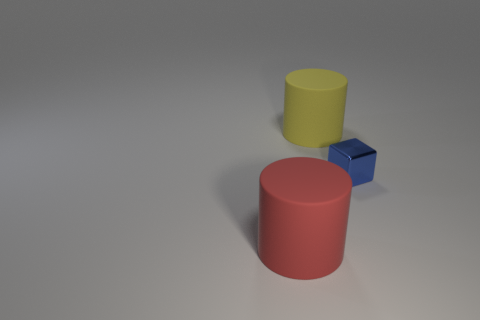What material is the thing right of the large matte object that is behind the object right of the large yellow cylinder made of?
Give a very brief answer. Metal. There is a object that is to the left of the tiny blue metallic object and on the right side of the red cylinder; what size is it?
Provide a short and direct response. Large. How many cylinders are tiny blue metal objects or matte things?
Keep it short and to the point. 2. There is another cylinder that is the same size as the yellow cylinder; what is its color?
Offer a very short reply. Red. Are there any other things that are the same shape as the shiny thing?
Your answer should be compact. No. The other large rubber object that is the same shape as the red rubber object is what color?
Provide a succinct answer. Yellow. How many things are large green metallic cylinders or things that are on the right side of the red cylinder?
Keep it short and to the point. 2. Are there fewer big yellow things that are right of the blue metal thing than red matte cylinders?
Keep it short and to the point. Yes. What is the size of the rubber thing that is left of the matte cylinder that is behind the large matte thing that is in front of the yellow cylinder?
Your answer should be very brief. Large. There is a object that is in front of the large yellow matte object and left of the tiny thing; what is its color?
Your response must be concise. Red. 